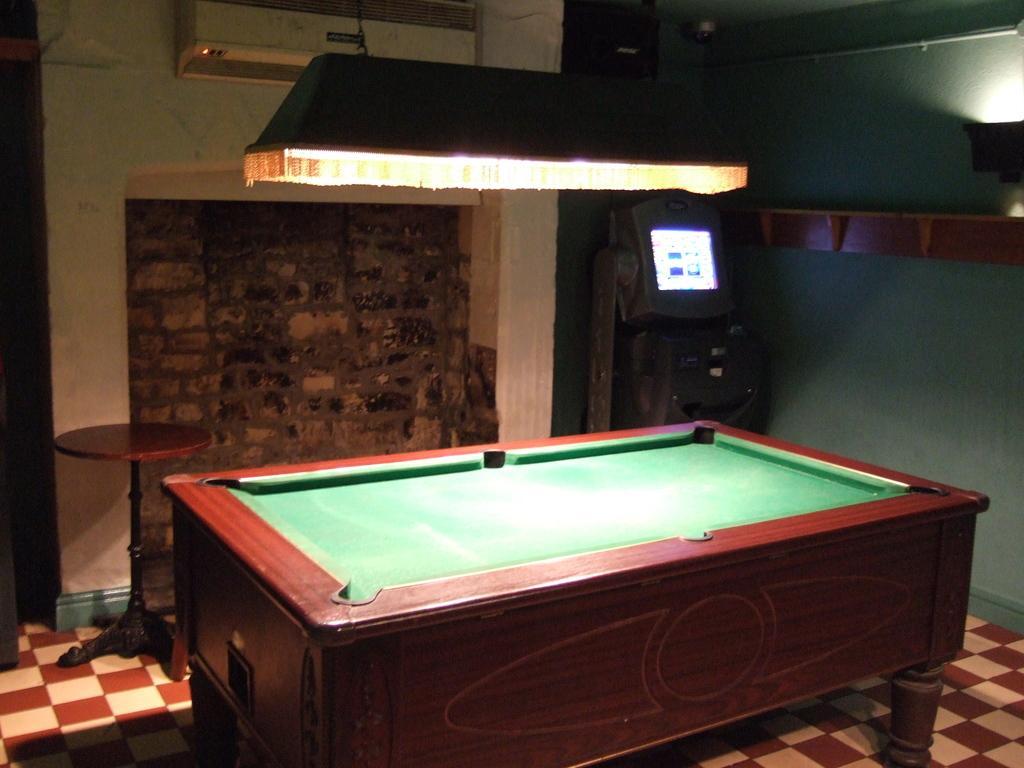How would you summarize this image in a sentence or two? As we can see in the image there is a wall, air conditioner, light, screen and billiards board. 